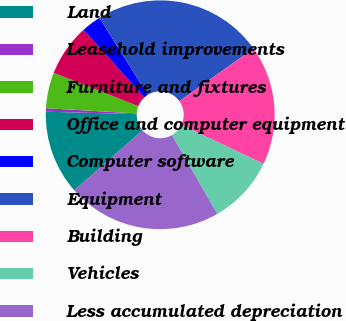Convert chart to OTSL. <chart><loc_0><loc_0><loc_500><loc_500><pie_chart><fcel>Land<fcel>Leasehold improvements<fcel>Furniture and fixtures<fcel>Office and computer equipment<fcel>Computer software<fcel>Equipment<fcel>Building<fcel>Vehicles<fcel>Less accumulated depreciation<nl><fcel>11.91%<fcel>0.49%<fcel>5.06%<fcel>7.34%<fcel>2.77%<fcel>24.1%<fcel>16.88%<fcel>9.63%<fcel>21.82%<nl></chart> 